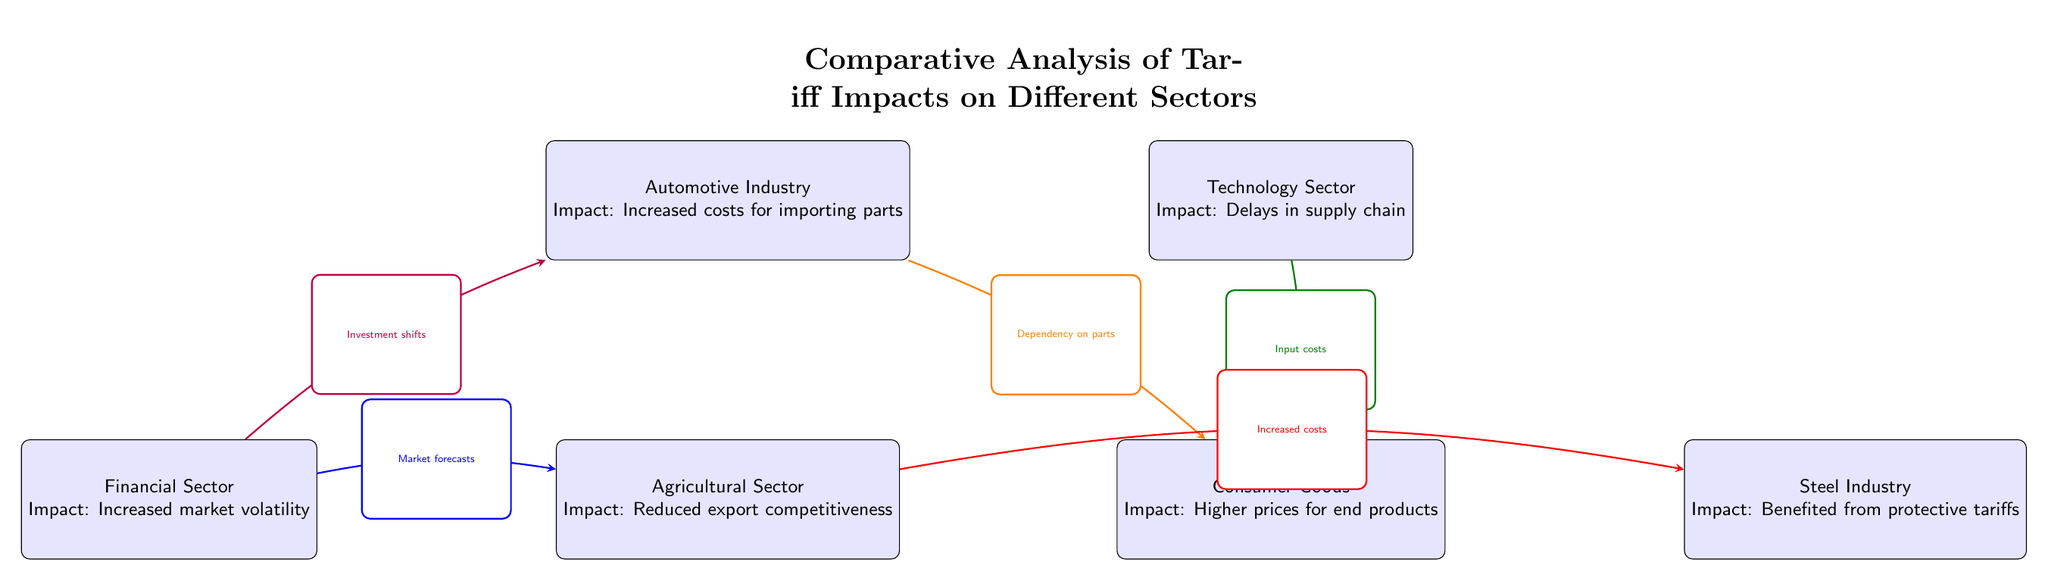What is the impact on the Automotive Industry? The diagram shows that the impact on the Automotive Industry is "Increased costs for importing parts."
Answer: Increased costs for importing parts How many sectors are represented in the diagram? A count of the nodes reveals there are six sectors depicted in the diagram.
Answer: Six Which sector is connected to the Agricultural Sector with the arrow labeled "Increased costs"? Tracing the arrow connections, the Steel Industry is connected to the Agricultural Sector with the label "Increased costs."
Answer: Steel Industry What does the arrow from the Technology Sector to Consumer Goods indicate? The arrow from the Technology Sector to Consumer Goods is labeled "Input costs," indicating that input costs from the technology sector affect consumer goods prices.
Answer: Input costs Which sector feels "Higher prices for end products" due to tariff impacts? The Consumer Goods sector is identified as feeling "Higher prices for end products" as a direct impact of tariffs.
Answer: Consumer Goods What relationship is indicated between the Financial Sector and the Automotive Industry? The diagram shows an arrow labeled "Investment shifts" pointing from the Financial Sector to the Automotive Industry, indicating a directional relationship.
Answer: Investment shifts Which sector benefits from protective tariffs according to the diagram? The diagram clearly marks the Steel Industry as benefiting from protective tariffs.
Answer: Steel Industry What is the impact on the Agricultural Sector? The impact on the Agricultural Sector is noted as "Reduced export competitiveness" in the diagram.
Answer: Reduced export competitiveness 